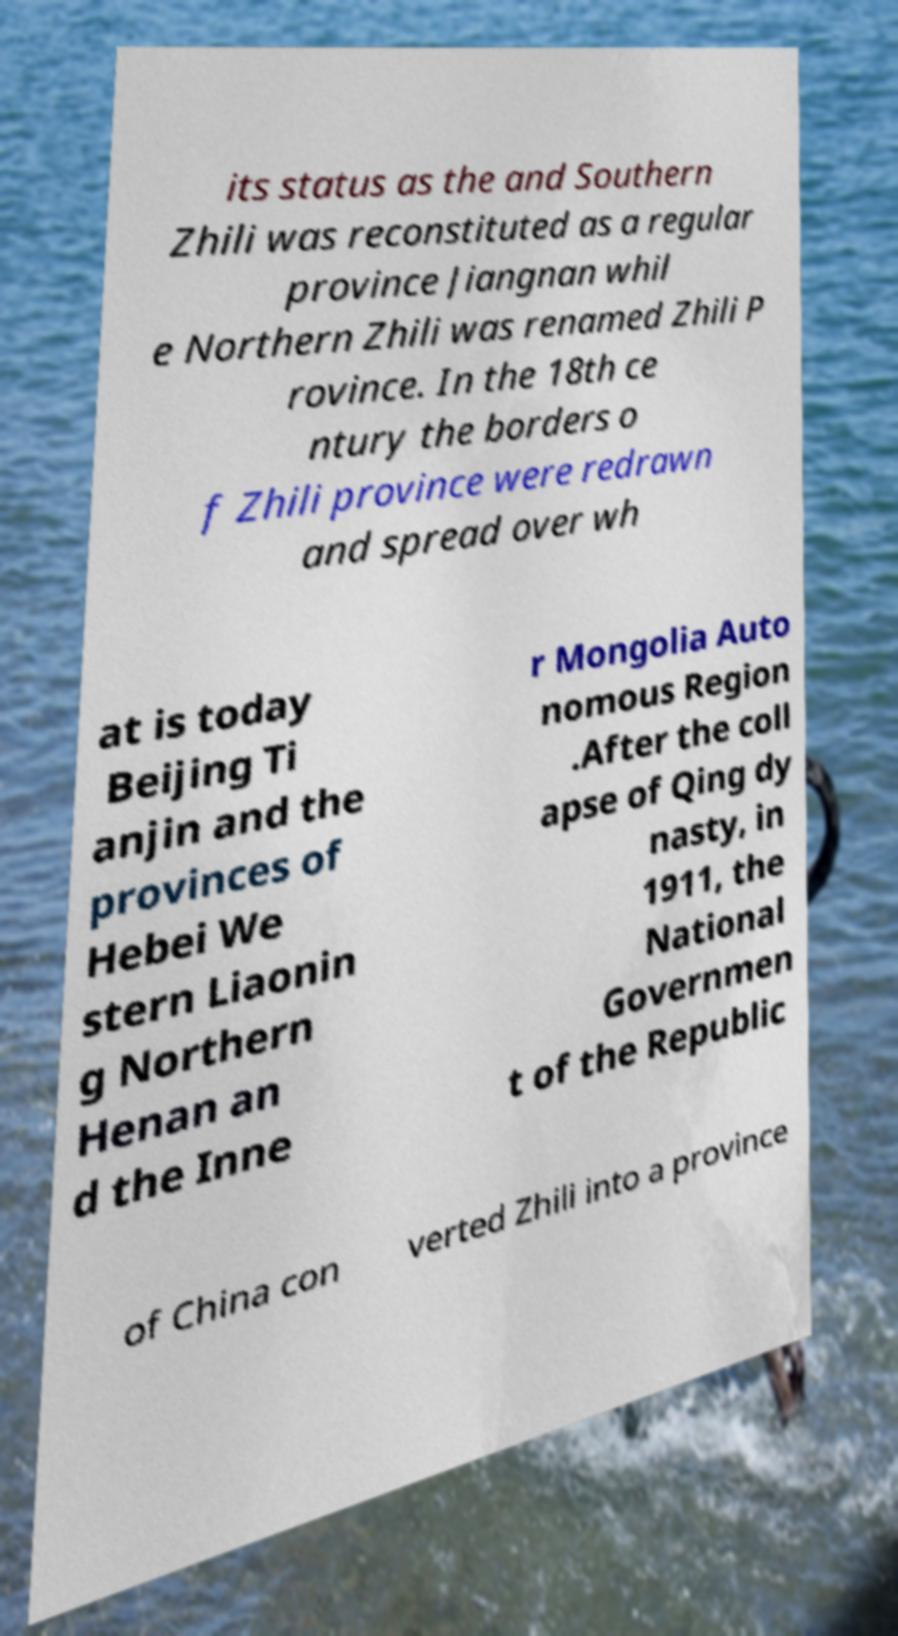Could you assist in decoding the text presented in this image and type it out clearly? its status as the and Southern Zhili was reconstituted as a regular province Jiangnan whil e Northern Zhili was renamed Zhili P rovince. In the 18th ce ntury the borders o f Zhili province were redrawn and spread over wh at is today Beijing Ti anjin and the provinces of Hebei We stern Liaonin g Northern Henan an d the Inne r Mongolia Auto nomous Region .After the coll apse of Qing dy nasty, in 1911, the National Governmen t of the Republic of China con verted Zhili into a province 